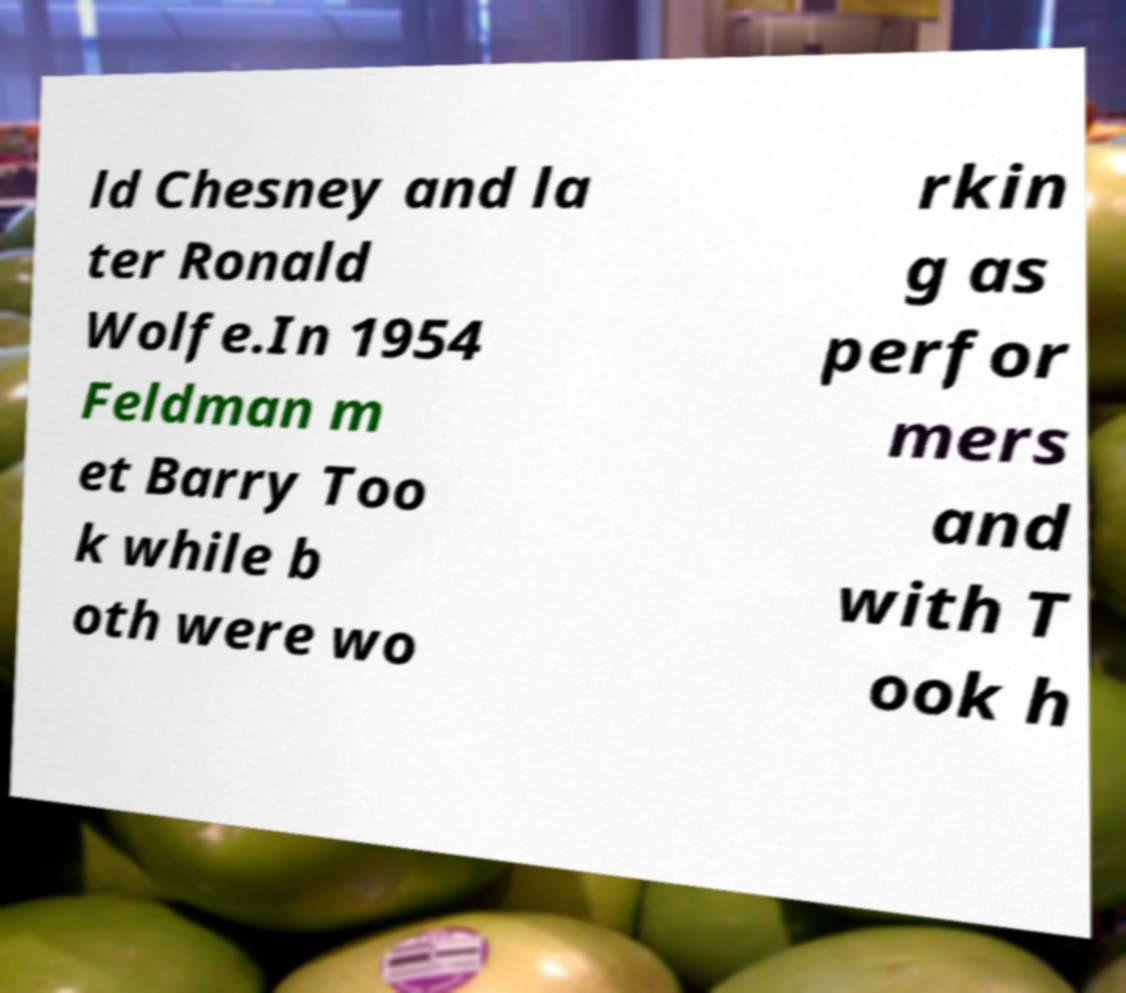Please identify and transcribe the text found in this image. ld Chesney and la ter Ronald Wolfe.In 1954 Feldman m et Barry Too k while b oth were wo rkin g as perfor mers and with T ook h 